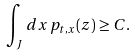<formula> <loc_0><loc_0><loc_500><loc_500>\int _ { J } d x \, p _ { t , x } ( z ) \geq C .</formula> 